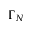Convert formula to latex. <formula><loc_0><loc_0><loc_500><loc_500>\Gamma _ { N }</formula> 